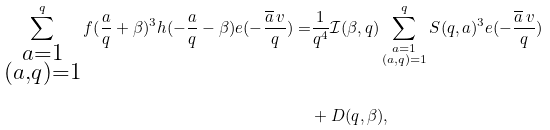<formula> <loc_0><loc_0><loc_500><loc_500>\sum _ { \substack { a = 1 \\ ( a , q ) = 1 } } ^ { q } f ( \frac { a } { q } + \beta ) ^ { 3 } h ( - \frac { a } { q } - \beta ) e ( - \frac { \overline { a } \, v } { q } ) = & \frac { 1 } { q ^ { 4 } } \mathcal { I } ( \beta , q ) \sum _ { \substack { a = 1 \\ ( a , q ) = 1 } } ^ { q } S ( q , a ) ^ { 3 } e ( - \frac { \overline { a } \, v } { q } ) \\ & + D ( q , \beta ) ,</formula> 